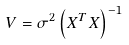<formula> <loc_0><loc_0><loc_500><loc_500>V = \sigma ^ { 2 } \left ( X ^ { T } X \right ) ^ { - 1 }</formula> 